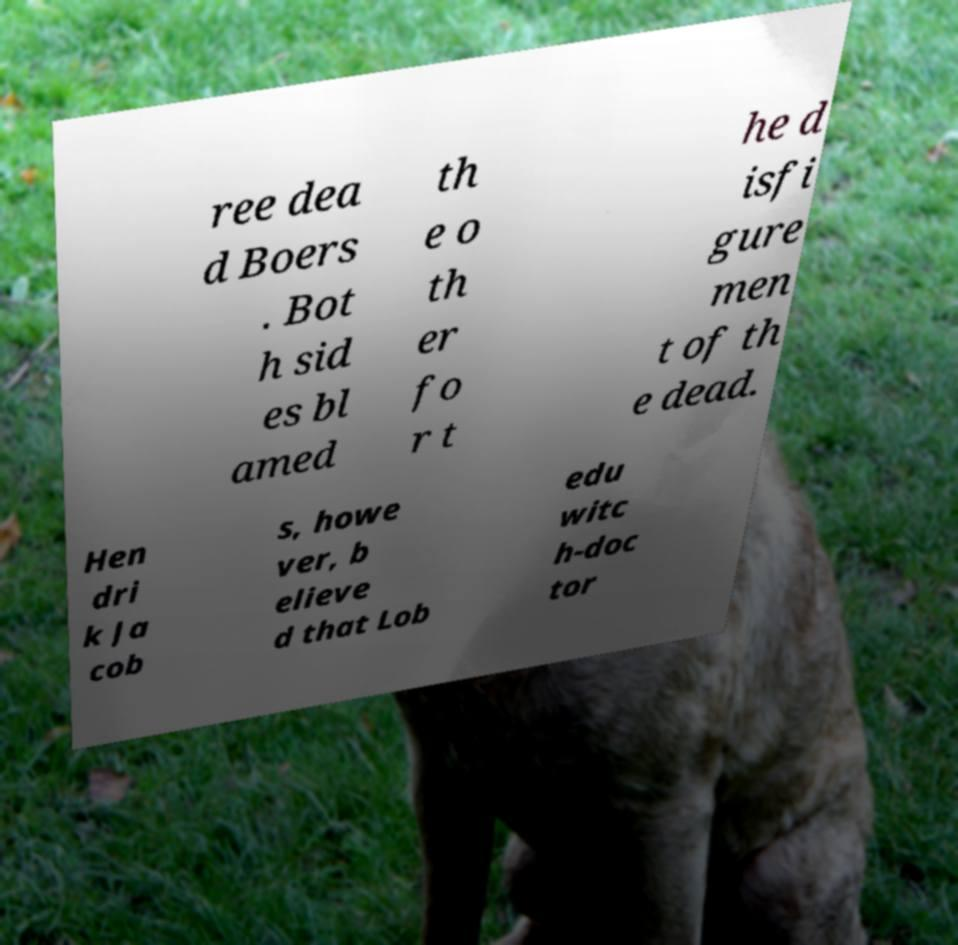Could you extract and type out the text from this image? ree dea d Boers . Bot h sid es bl amed th e o th er fo r t he d isfi gure men t of th e dead. Hen dri k Ja cob s, howe ver, b elieve d that Lob edu witc h-doc tor 